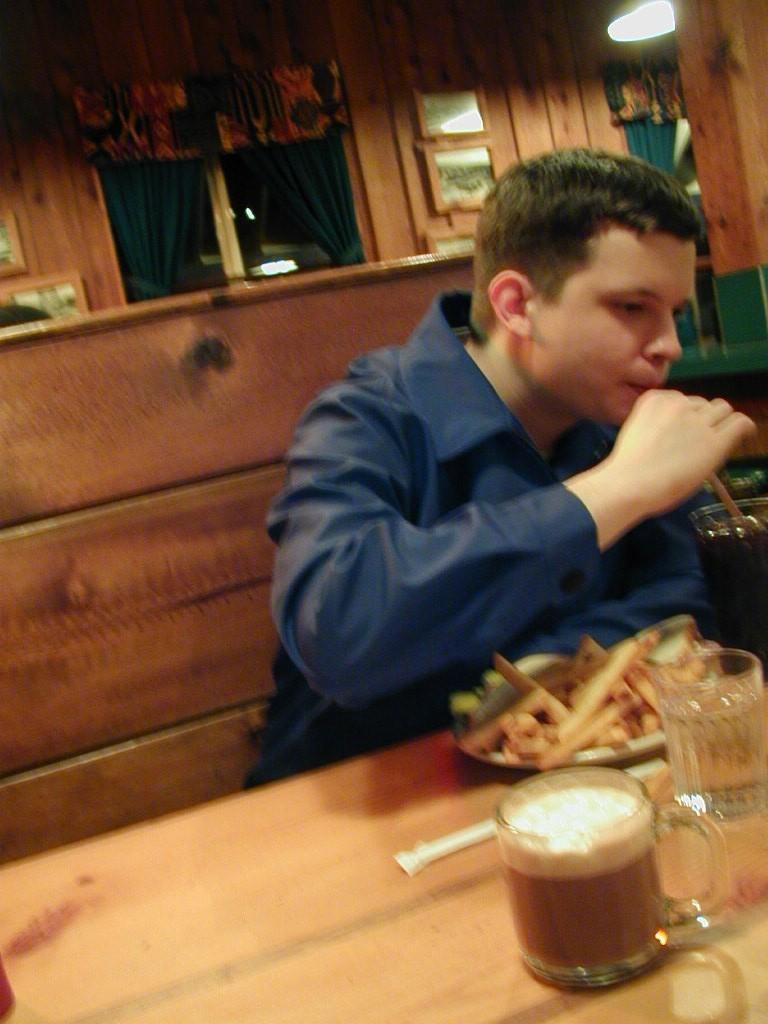Please provide a concise description of this image. In this picture we can see a man holding a straw with his hand and drinking. On the table we can see a cup and a drink in, a water glass, a plate of snacks. He is sitting on a chair. On the background we can see window, photo frames , lights 